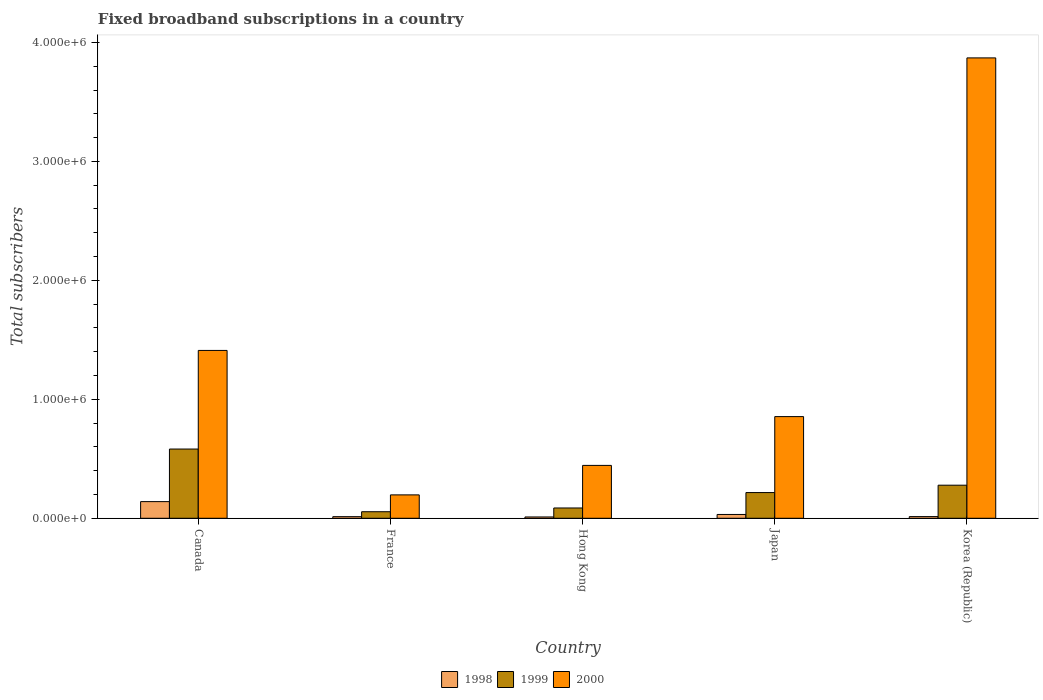Are the number of bars per tick equal to the number of legend labels?
Your answer should be compact. Yes. How many bars are there on the 3rd tick from the left?
Give a very brief answer. 3. What is the label of the 3rd group of bars from the left?
Provide a short and direct response. Hong Kong. In how many cases, is the number of bars for a given country not equal to the number of legend labels?
Offer a terse response. 0. What is the number of broadband subscriptions in 2000 in Canada?
Your answer should be compact. 1.41e+06. Across all countries, what is the maximum number of broadband subscriptions in 1999?
Offer a very short reply. 5.82e+05. Across all countries, what is the minimum number of broadband subscriptions in 2000?
Provide a short and direct response. 1.97e+05. In which country was the number of broadband subscriptions in 1998 minimum?
Provide a short and direct response. Hong Kong. What is the total number of broadband subscriptions in 2000 in the graph?
Offer a very short reply. 6.78e+06. What is the difference between the number of broadband subscriptions in 2000 in France and that in Japan?
Make the answer very short. -6.58e+05. What is the difference between the number of broadband subscriptions in 2000 in Canada and the number of broadband subscriptions in 1998 in Japan?
Keep it short and to the point. 1.38e+06. What is the average number of broadband subscriptions in 1998 per country?
Offer a very short reply. 4.21e+04. What is the difference between the number of broadband subscriptions of/in 1999 and number of broadband subscriptions of/in 1998 in Japan?
Provide a succinct answer. 1.84e+05. In how many countries, is the number of broadband subscriptions in 2000 greater than 800000?
Offer a very short reply. 3. What is the ratio of the number of broadband subscriptions in 1998 in Hong Kong to that in Korea (Republic)?
Your answer should be very brief. 0.79. Is the number of broadband subscriptions in 2000 in Hong Kong less than that in Japan?
Ensure brevity in your answer.  Yes. Is the difference between the number of broadband subscriptions in 1999 in Canada and Korea (Republic) greater than the difference between the number of broadband subscriptions in 1998 in Canada and Korea (Republic)?
Provide a short and direct response. Yes. What is the difference between the highest and the second highest number of broadband subscriptions in 2000?
Make the answer very short. 2.46e+06. What is the difference between the highest and the lowest number of broadband subscriptions in 1998?
Make the answer very short. 1.29e+05. In how many countries, is the number of broadband subscriptions in 2000 greater than the average number of broadband subscriptions in 2000 taken over all countries?
Provide a succinct answer. 2. Is the sum of the number of broadband subscriptions in 1999 in Canada and Japan greater than the maximum number of broadband subscriptions in 1998 across all countries?
Your answer should be compact. Yes. What does the 1st bar from the right in Canada represents?
Provide a succinct answer. 2000. Is it the case that in every country, the sum of the number of broadband subscriptions in 1999 and number of broadband subscriptions in 1998 is greater than the number of broadband subscriptions in 2000?
Offer a very short reply. No. How many bars are there?
Your answer should be very brief. 15. Are all the bars in the graph horizontal?
Offer a very short reply. No. Are the values on the major ticks of Y-axis written in scientific E-notation?
Your response must be concise. Yes. Does the graph contain any zero values?
Your response must be concise. No. Does the graph contain grids?
Offer a terse response. No. How many legend labels are there?
Your answer should be very brief. 3. What is the title of the graph?
Your answer should be compact. Fixed broadband subscriptions in a country. Does "2006" appear as one of the legend labels in the graph?
Keep it short and to the point. No. What is the label or title of the Y-axis?
Make the answer very short. Total subscribers. What is the Total subscribers in 1999 in Canada?
Your answer should be very brief. 5.82e+05. What is the Total subscribers of 2000 in Canada?
Offer a terse response. 1.41e+06. What is the Total subscribers of 1998 in France?
Your response must be concise. 1.35e+04. What is the Total subscribers in 1999 in France?
Offer a very short reply. 5.50e+04. What is the Total subscribers in 2000 in France?
Your response must be concise. 1.97e+05. What is the Total subscribers of 1998 in Hong Kong?
Keep it short and to the point. 1.10e+04. What is the Total subscribers of 1999 in Hong Kong?
Provide a short and direct response. 8.65e+04. What is the Total subscribers of 2000 in Hong Kong?
Keep it short and to the point. 4.44e+05. What is the Total subscribers in 1998 in Japan?
Your answer should be compact. 3.20e+04. What is the Total subscribers of 1999 in Japan?
Provide a succinct answer. 2.16e+05. What is the Total subscribers of 2000 in Japan?
Provide a short and direct response. 8.55e+05. What is the Total subscribers of 1998 in Korea (Republic)?
Make the answer very short. 1.40e+04. What is the Total subscribers in 1999 in Korea (Republic)?
Make the answer very short. 2.78e+05. What is the Total subscribers in 2000 in Korea (Republic)?
Offer a terse response. 3.87e+06. Across all countries, what is the maximum Total subscribers of 1998?
Keep it short and to the point. 1.40e+05. Across all countries, what is the maximum Total subscribers of 1999?
Offer a very short reply. 5.82e+05. Across all countries, what is the maximum Total subscribers in 2000?
Make the answer very short. 3.87e+06. Across all countries, what is the minimum Total subscribers in 1998?
Your answer should be compact. 1.10e+04. Across all countries, what is the minimum Total subscribers of 1999?
Provide a short and direct response. 5.50e+04. Across all countries, what is the minimum Total subscribers of 2000?
Make the answer very short. 1.97e+05. What is the total Total subscribers in 1998 in the graph?
Make the answer very short. 2.10e+05. What is the total Total subscribers of 1999 in the graph?
Offer a very short reply. 1.22e+06. What is the total Total subscribers in 2000 in the graph?
Provide a short and direct response. 6.78e+06. What is the difference between the Total subscribers of 1998 in Canada and that in France?
Your answer should be very brief. 1.27e+05. What is the difference between the Total subscribers of 1999 in Canada and that in France?
Offer a terse response. 5.27e+05. What is the difference between the Total subscribers in 2000 in Canada and that in France?
Keep it short and to the point. 1.21e+06. What is the difference between the Total subscribers of 1998 in Canada and that in Hong Kong?
Your answer should be compact. 1.29e+05. What is the difference between the Total subscribers in 1999 in Canada and that in Hong Kong?
Keep it short and to the point. 4.96e+05. What is the difference between the Total subscribers of 2000 in Canada and that in Hong Kong?
Keep it short and to the point. 9.66e+05. What is the difference between the Total subscribers in 1998 in Canada and that in Japan?
Provide a succinct answer. 1.08e+05. What is the difference between the Total subscribers in 1999 in Canada and that in Japan?
Offer a very short reply. 3.66e+05. What is the difference between the Total subscribers in 2000 in Canada and that in Japan?
Keep it short and to the point. 5.56e+05. What is the difference between the Total subscribers in 1998 in Canada and that in Korea (Republic)?
Your answer should be very brief. 1.26e+05. What is the difference between the Total subscribers of 1999 in Canada and that in Korea (Republic)?
Give a very brief answer. 3.04e+05. What is the difference between the Total subscribers of 2000 in Canada and that in Korea (Republic)?
Offer a very short reply. -2.46e+06. What is the difference between the Total subscribers of 1998 in France and that in Hong Kong?
Your response must be concise. 2464. What is the difference between the Total subscribers of 1999 in France and that in Hong Kong?
Keep it short and to the point. -3.15e+04. What is the difference between the Total subscribers in 2000 in France and that in Hong Kong?
Ensure brevity in your answer.  -2.48e+05. What is the difference between the Total subscribers of 1998 in France and that in Japan?
Provide a short and direct response. -1.85e+04. What is the difference between the Total subscribers in 1999 in France and that in Japan?
Your answer should be very brief. -1.61e+05. What is the difference between the Total subscribers of 2000 in France and that in Japan?
Provide a short and direct response. -6.58e+05. What is the difference between the Total subscribers in 1998 in France and that in Korea (Republic)?
Keep it short and to the point. -536. What is the difference between the Total subscribers in 1999 in France and that in Korea (Republic)?
Keep it short and to the point. -2.23e+05. What is the difference between the Total subscribers in 2000 in France and that in Korea (Republic)?
Your response must be concise. -3.67e+06. What is the difference between the Total subscribers in 1998 in Hong Kong and that in Japan?
Offer a terse response. -2.10e+04. What is the difference between the Total subscribers in 1999 in Hong Kong and that in Japan?
Offer a terse response. -1.30e+05. What is the difference between the Total subscribers in 2000 in Hong Kong and that in Japan?
Your answer should be compact. -4.10e+05. What is the difference between the Total subscribers of 1998 in Hong Kong and that in Korea (Republic)?
Keep it short and to the point. -3000. What is the difference between the Total subscribers in 1999 in Hong Kong and that in Korea (Republic)?
Your answer should be very brief. -1.92e+05. What is the difference between the Total subscribers in 2000 in Hong Kong and that in Korea (Republic)?
Offer a terse response. -3.43e+06. What is the difference between the Total subscribers in 1998 in Japan and that in Korea (Republic)?
Make the answer very short. 1.80e+04. What is the difference between the Total subscribers of 1999 in Japan and that in Korea (Republic)?
Your answer should be very brief. -6.20e+04. What is the difference between the Total subscribers in 2000 in Japan and that in Korea (Republic)?
Give a very brief answer. -3.02e+06. What is the difference between the Total subscribers of 1998 in Canada and the Total subscribers of 1999 in France?
Your response must be concise. 8.50e+04. What is the difference between the Total subscribers in 1998 in Canada and the Total subscribers in 2000 in France?
Make the answer very short. -5.66e+04. What is the difference between the Total subscribers in 1999 in Canada and the Total subscribers in 2000 in France?
Your answer should be very brief. 3.85e+05. What is the difference between the Total subscribers in 1998 in Canada and the Total subscribers in 1999 in Hong Kong?
Provide a short and direct response. 5.35e+04. What is the difference between the Total subscribers in 1998 in Canada and the Total subscribers in 2000 in Hong Kong?
Offer a terse response. -3.04e+05. What is the difference between the Total subscribers in 1999 in Canada and the Total subscribers in 2000 in Hong Kong?
Offer a terse response. 1.38e+05. What is the difference between the Total subscribers of 1998 in Canada and the Total subscribers of 1999 in Japan?
Offer a very short reply. -7.60e+04. What is the difference between the Total subscribers in 1998 in Canada and the Total subscribers in 2000 in Japan?
Provide a succinct answer. -7.15e+05. What is the difference between the Total subscribers of 1999 in Canada and the Total subscribers of 2000 in Japan?
Give a very brief answer. -2.73e+05. What is the difference between the Total subscribers in 1998 in Canada and the Total subscribers in 1999 in Korea (Republic)?
Your answer should be compact. -1.38e+05. What is the difference between the Total subscribers in 1998 in Canada and the Total subscribers in 2000 in Korea (Republic)?
Keep it short and to the point. -3.73e+06. What is the difference between the Total subscribers in 1999 in Canada and the Total subscribers in 2000 in Korea (Republic)?
Offer a very short reply. -3.29e+06. What is the difference between the Total subscribers of 1998 in France and the Total subscribers of 1999 in Hong Kong?
Make the answer very short. -7.30e+04. What is the difference between the Total subscribers of 1998 in France and the Total subscribers of 2000 in Hong Kong?
Offer a very short reply. -4.31e+05. What is the difference between the Total subscribers in 1999 in France and the Total subscribers in 2000 in Hong Kong?
Keep it short and to the point. -3.89e+05. What is the difference between the Total subscribers in 1998 in France and the Total subscribers in 1999 in Japan?
Offer a very short reply. -2.03e+05. What is the difference between the Total subscribers of 1998 in France and the Total subscribers of 2000 in Japan?
Ensure brevity in your answer.  -8.41e+05. What is the difference between the Total subscribers in 1999 in France and the Total subscribers in 2000 in Japan?
Give a very brief answer. -8.00e+05. What is the difference between the Total subscribers in 1998 in France and the Total subscribers in 1999 in Korea (Republic)?
Your answer should be very brief. -2.65e+05. What is the difference between the Total subscribers in 1998 in France and the Total subscribers in 2000 in Korea (Republic)?
Your answer should be very brief. -3.86e+06. What is the difference between the Total subscribers in 1999 in France and the Total subscribers in 2000 in Korea (Republic)?
Make the answer very short. -3.82e+06. What is the difference between the Total subscribers in 1998 in Hong Kong and the Total subscribers in 1999 in Japan?
Keep it short and to the point. -2.05e+05. What is the difference between the Total subscribers of 1998 in Hong Kong and the Total subscribers of 2000 in Japan?
Your answer should be compact. -8.44e+05. What is the difference between the Total subscribers of 1999 in Hong Kong and the Total subscribers of 2000 in Japan?
Offer a very short reply. -7.68e+05. What is the difference between the Total subscribers of 1998 in Hong Kong and the Total subscribers of 1999 in Korea (Republic)?
Provide a succinct answer. -2.67e+05. What is the difference between the Total subscribers in 1998 in Hong Kong and the Total subscribers in 2000 in Korea (Republic)?
Make the answer very short. -3.86e+06. What is the difference between the Total subscribers of 1999 in Hong Kong and the Total subscribers of 2000 in Korea (Republic)?
Give a very brief answer. -3.78e+06. What is the difference between the Total subscribers of 1998 in Japan and the Total subscribers of 1999 in Korea (Republic)?
Your response must be concise. -2.46e+05. What is the difference between the Total subscribers in 1998 in Japan and the Total subscribers in 2000 in Korea (Republic)?
Keep it short and to the point. -3.84e+06. What is the difference between the Total subscribers of 1999 in Japan and the Total subscribers of 2000 in Korea (Republic)?
Ensure brevity in your answer.  -3.65e+06. What is the average Total subscribers of 1998 per country?
Provide a short and direct response. 4.21e+04. What is the average Total subscribers in 1999 per country?
Give a very brief answer. 2.43e+05. What is the average Total subscribers of 2000 per country?
Your answer should be compact. 1.36e+06. What is the difference between the Total subscribers in 1998 and Total subscribers in 1999 in Canada?
Make the answer very short. -4.42e+05. What is the difference between the Total subscribers in 1998 and Total subscribers in 2000 in Canada?
Keep it short and to the point. -1.27e+06. What is the difference between the Total subscribers in 1999 and Total subscribers in 2000 in Canada?
Offer a very short reply. -8.29e+05. What is the difference between the Total subscribers of 1998 and Total subscribers of 1999 in France?
Keep it short and to the point. -4.15e+04. What is the difference between the Total subscribers in 1998 and Total subscribers in 2000 in France?
Offer a very short reply. -1.83e+05. What is the difference between the Total subscribers of 1999 and Total subscribers of 2000 in France?
Your answer should be very brief. -1.42e+05. What is the difference between the Total subscribers in 1998 and Total subscribers in 1999 in Hong Kong?
Your answer should be compact. -7.55e+04. What is the difference between the Total subscribers of 1998 and Total subscribers of 2000 in Hong Kong?
Offer a terse response. -4.33e+05. What is the difference between the Total subscribers in 1999 and Total subscribers in 2000 in Hong Kong?
Provide a short and direct response. -3.58e+05. What is the difference between the Total subscribers in 1998 and Total subscribers in 1999 in Japan?
Your answer should be very brief. -1.84e+05. What is the difference between the Total subscribers of 1998 and Total subscribers of 2000 in Japan?
Offer a terse response. -8.23e+05. What is the difference between the Total subscribers of 1999 and Total subscribers of 2000 in Japan?
Offer a terse response. -6.39e+05. What is the difference between the Total subscribers in 1998 and Total subscribers in 1999 in Korea (Republic)?
Ensure brevity in your answer.  -2.64e+05. What is the difference between the Total subscribers of 1998 and Total subscribers of 2000 in Korea (Republic)?
Keep it short and to the point. -3.86e+06. What is the difference between the Total subscribers in 1999 and Total subscribers in 2000 in Korea (Republic)?
Give a very brief answer. -3.59e+06. What is the ratio of the Total subscribers of 1998 in Canada to that in France?
Ensure brevity in your answer.  10.4. What is the ratio of the Total subscribers in 1999 in Canada to that in France?
Keep it short and to the point. 10.58. What is the ratio of the Total subscribers of 2000 in Canada to that in France?
Provide a short and direct response. 7.18. What is the ratio of the Total subscribers of 1998 in Canada to that in Hong Kong?
Ensure brevity in your answer.  12.73. What is the ratio of the Total subscribers in 1999 in Canada to that in Hong Kong?
Offer a terse response. 6.73. What is the ratio of the Total subscribers in 2000 in Canada to that in Hong Kong?
Your answer should be very brief. 3.17. What is the ratio of the Total subscribers in 1998 in Canada to that in Japan?
Offer a very short reply. 4.38. What is the ratio of the Total subscribers in 1999 in Canada to that in Japan?
Provide a short and direct response. 2.69. What is the ratio of the Total subscribers of 2000 in Canada to that in Japan?
Keep it short and to the point. 1.65. What is the ratio of the Total subscribers in 1998 in Canada to that in Korea (Republic)?
Ensure brevity in your answer.  10. What is the ratio of the Total subscribers in 1999 in Canada to that in Korea (Republic)?
Offer a terse response. 2.09. What is the ratio of the Total subscribers of 2000 in Canada to that in Korea (Republic)?
Keep it short and to the point. 0.36. What is the ratio of the Total subscribers in 1998 in France to that in Hong Kong?
Give a very brief answer. 1.22. What is the ratio of the Total subscribers of 1999 in France to that in Hong Kong?
Provide a short and direct response. 0.64. What is the ratio of the Total subscribers of 2000 in France to that in Hong Kong?
Provide a short and direct response. 0.44. What is the ratio of the Total subscribers of 1998 in France to that in Japan?
Your response must be concise. 0.42. What is the ratio of the Total subscribers of 1999 in France to that in Japan?
Offer a very short reply. 0.25. What is the ratio of the Total subscribers in 2000 in France to that in Japan?
Offer a very short reply. 0.23. What is the ratio of the Total subscribers of 1998 in France to that in Korea (Republic)?
Provide a short and direct response. 0.96. What is the ratio of the Total subscribers of 1999 in France to that in Korea (Republic)?
Make the answer very short. 0.2. What is the ratio of the Total subscribers in 2000 in France to that in Korea (Republic)?
Offer a very short reply. 0.05. What is the ratio of the Total subscribers of 1998 in Hong Kong to that in Japan?
Give a very brief answer. 0.34. What is the ratio of the Total subscribers of 1999 in Hong Kong to that in Japan?
Make the answer very short. 0.4. What is the ratio of the Total subscribers of 2000 in Hong Kong to that in Japan?
Your answer should be compact. 0.52. What is the ratio of the Total subscribers of 1998 in Hong Kong to that in Korea (Republic)?
Ensure brevity in your answer.  0.79. What is the ratio of the Total subscribers in 1999 in Hong Kong to that in Korea (Republic)?
Give a very brief answer. 0.31. What is the ratio of the Total subscribers of 2000 in Hong Kong to that in Korea (Republic)?
Your response must be concise. 0.11. What is the ratio of the Total subscribers of 1998 in Japan to that in Korea (Republic)?
Provide a succinct answer. 2.29. What is the ratio of the Total subscribers of 1999 in Japan to that in Korea (Republic)?
Your response must be concise. 0.78. What is the ratio of the Total subscribers in 2000 in Japan to that in Korea (Republic)?
Make the answer very short. 0.22. What is the difference between the highest and the second highest Total subscribers of 1998?
Your answer should be compact. 1.08e+05. What is the difference between the highest and the second highest Total subscribers of 1999?
Your response must be concise. 3.04e+05. What is the difference between the highest and the second highest Total subscribers in 2000?
Keep it short and to the point. 2.46e+06. What is the difference between the highest and the lowest Total subscribers in 1998?
Offer a terse response. 1.29e+05. What is the difference between the highest and the lowest Total subscribers in 1999?
Provide a short and direct response. 5.27e+05. What is the difference between the highest and the lowest Total subscribers in 2000?
Keep it short and to the point. 3.67e+06. 